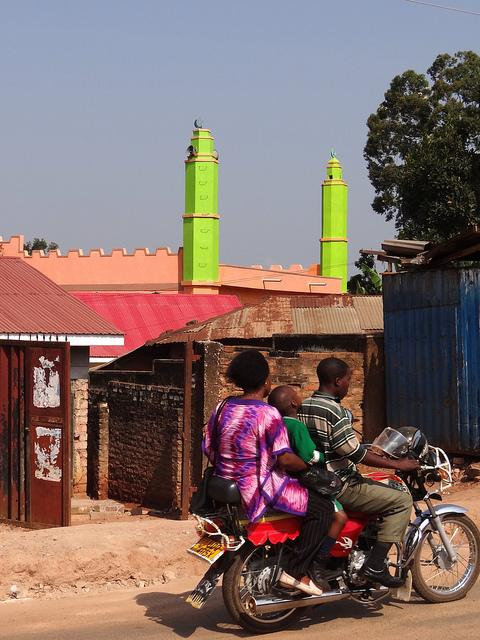Why are three people on the bike?

Choices:
A) dare
B) bet
C) cheap transportation
D) in hurry cheap transportation 